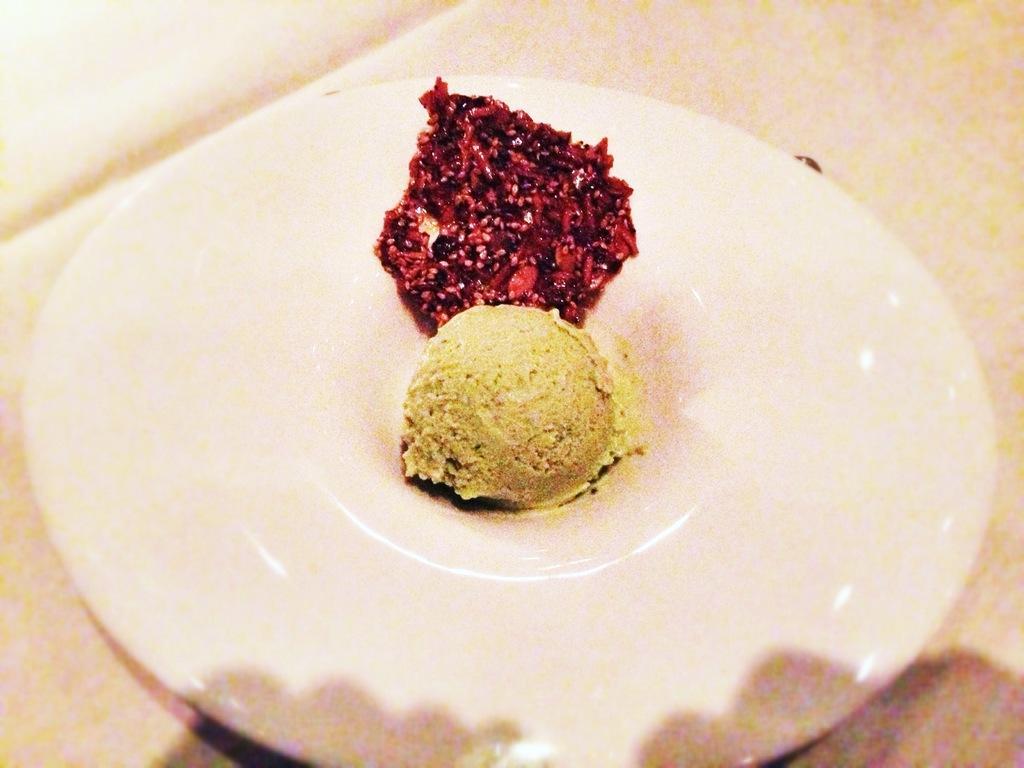Please provide a concise description of this image. In the center of the image there is a plate in which there are food items. At the bottom of the image there is table. 